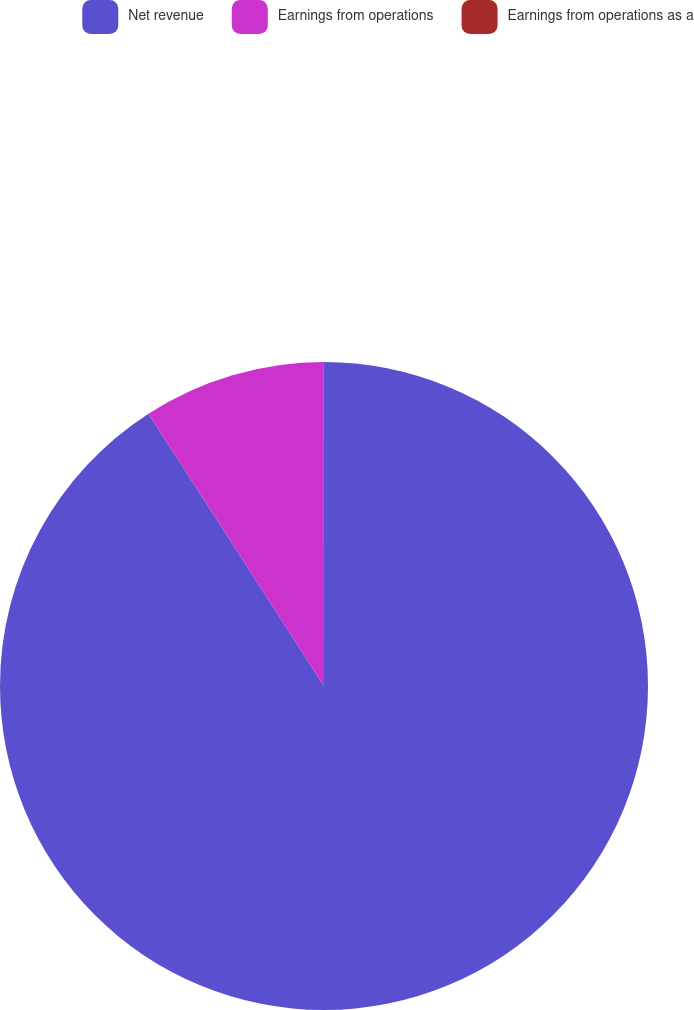<chart> <loc_0><loc_0><loc_500><loc_500><pie_chart><fcel>Net revenue<fcel>Earnings from operations<fcel>Earnings from operations as a<nl><fcel>90.89%<fcel>9.1%<fcel>0.01%<nl></chart> 